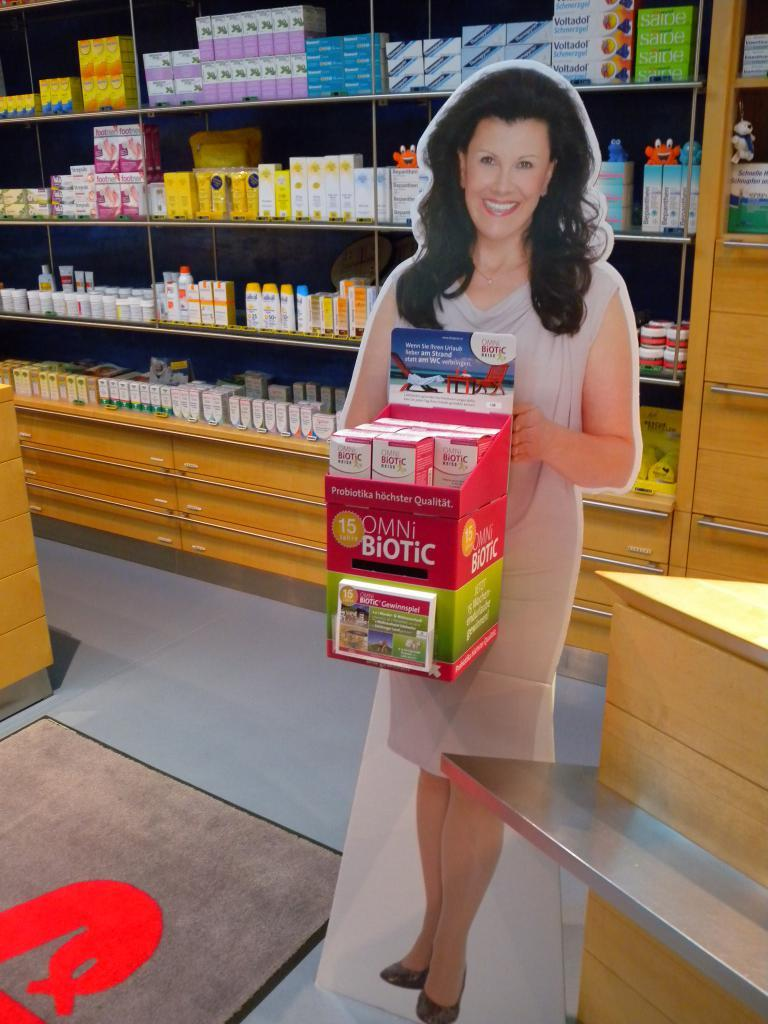<image>
Provide a brief description of the given image. A cardboard cutout of a lady holding a Biotic box 